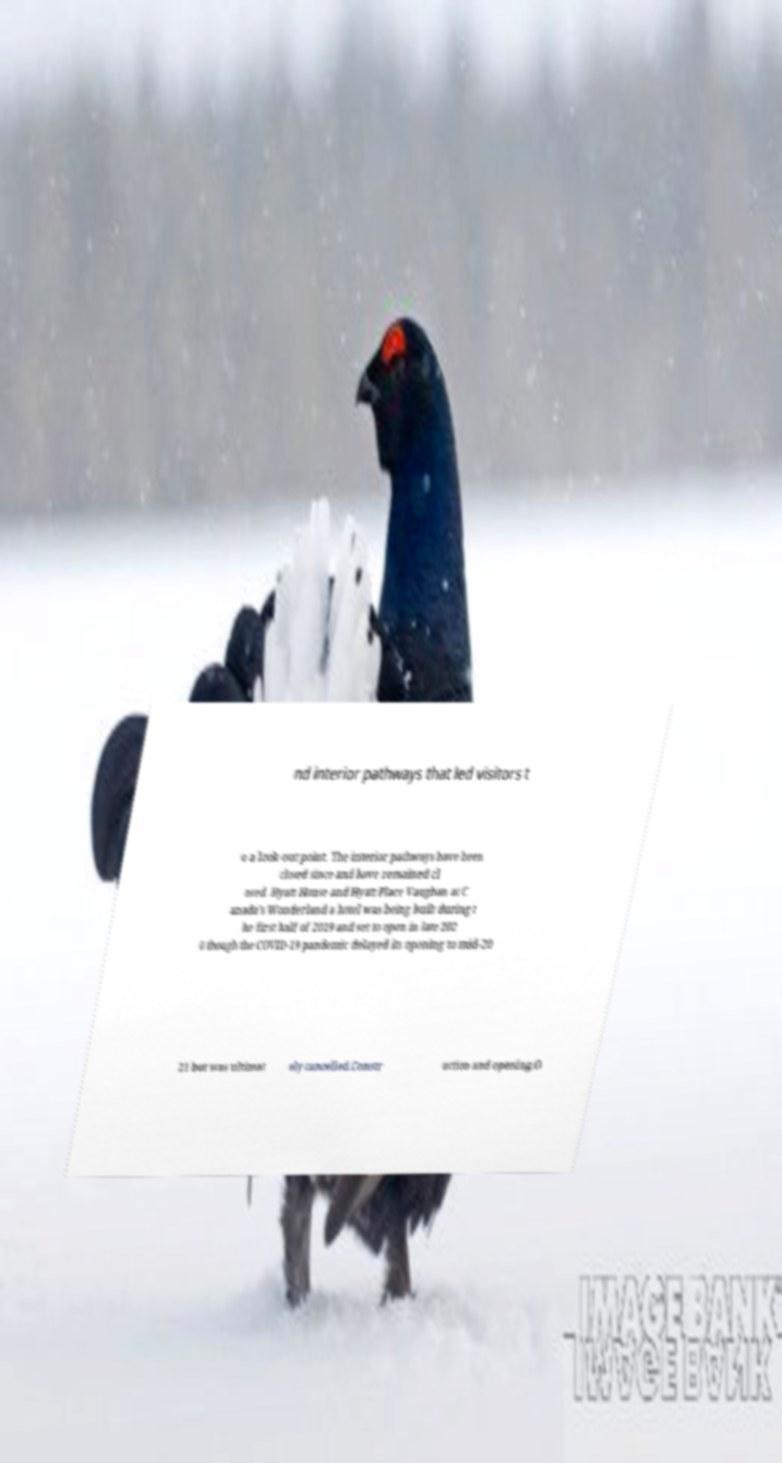I need the written content from this picture converted into text. Can you do that? nd interior pathways that led visitors t o a look-out point. The interior pathways have been closed since and have remained cl osed. Hyatt House and Hyatt Place Vaughan at C anada's Wonderland a hotel was being built during t he first half of 2019 and set to open in late 202 0 though the COVID-19 pandemic delayed its opening to mid-20 21 but was ultimat ely cancelled.Constr uction and opening.O 